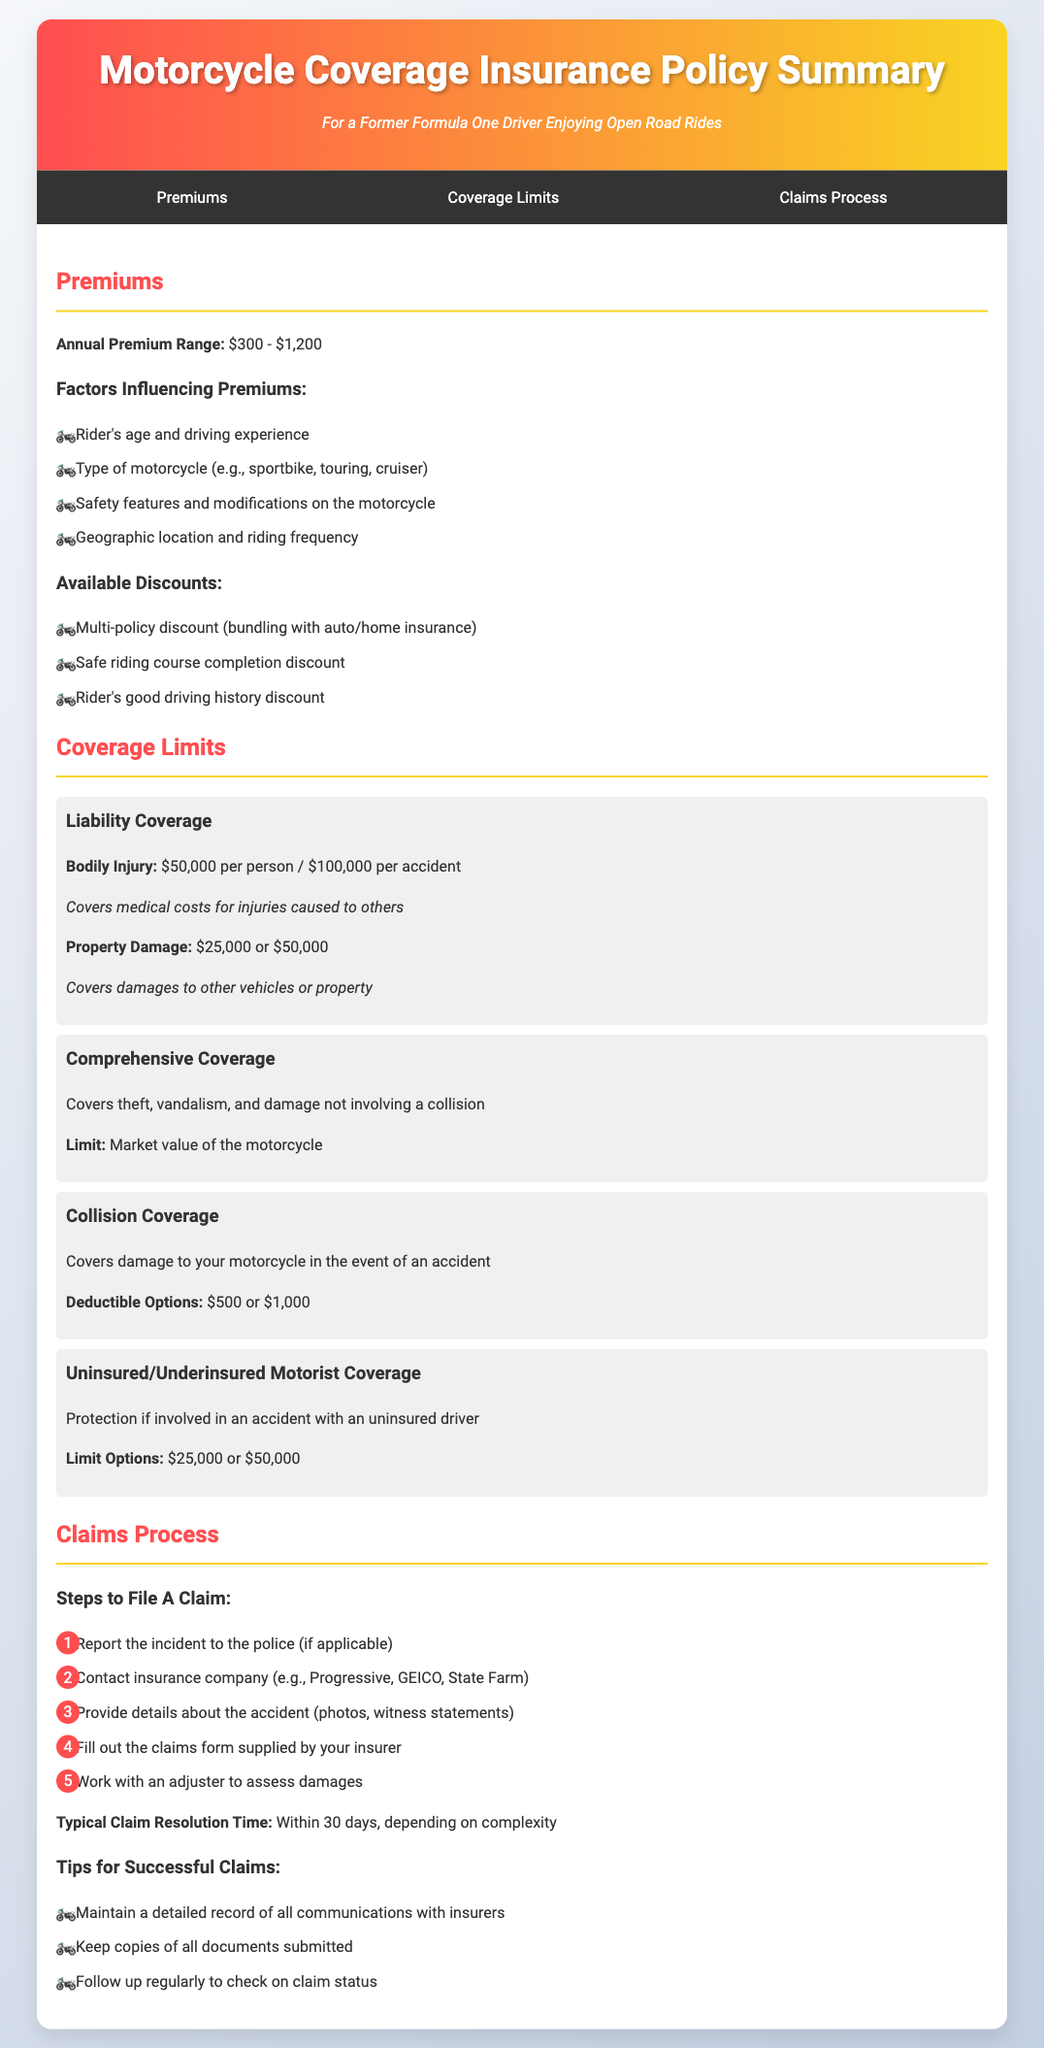what is the annual premium range? The annual premium range for motorcycle coverage is mentioned in the premiums section as $300 - $1,200.
Answer: $300 - $1,200 what factors influence premiums? The factors influencing premiums include the rider's age, type of motorcycle, safety features, and geographic location.
Answer: Rider's age and driving experience, type of motorcycle, safety features, geographic location what are the limits for liability coverage? The limits for liability coverage are specified for bodily injury and property damage in the coverage limits section.
Answer: $50,000 per person / $100,000 per accident; $25,000 or $50,000 how long is the typical claim resolution time? The typical claim resolution time is provided in the claims process section.
Answer: Within 30 days what is the deductible option for collision coverage? The deductible options for collision coverage are detailed in the coverage limits section.
Answer: $500 or $1,000 which discount is available for completing a safe riding course? The available discount for completing a safe riding course is mentioned under the discounts section in the premiums area.
Answer: Safe riding course completion discount what should you do first when filing a claim? The first step in the claims process is highlighted as reporting the incident to the police, if applicable.
Answer: Report the incident to the police what types of comprehensive coverage are included? The comprehensive coverage section states the types of events that it covers.
Answer: Theft, vandalism, and damage not involving a collision what is a tip for successful claims? One tip for successful claims mentioned in the document involves maintaining detailed records.
Answer: Maintain a detailed record of all communications with insurers 